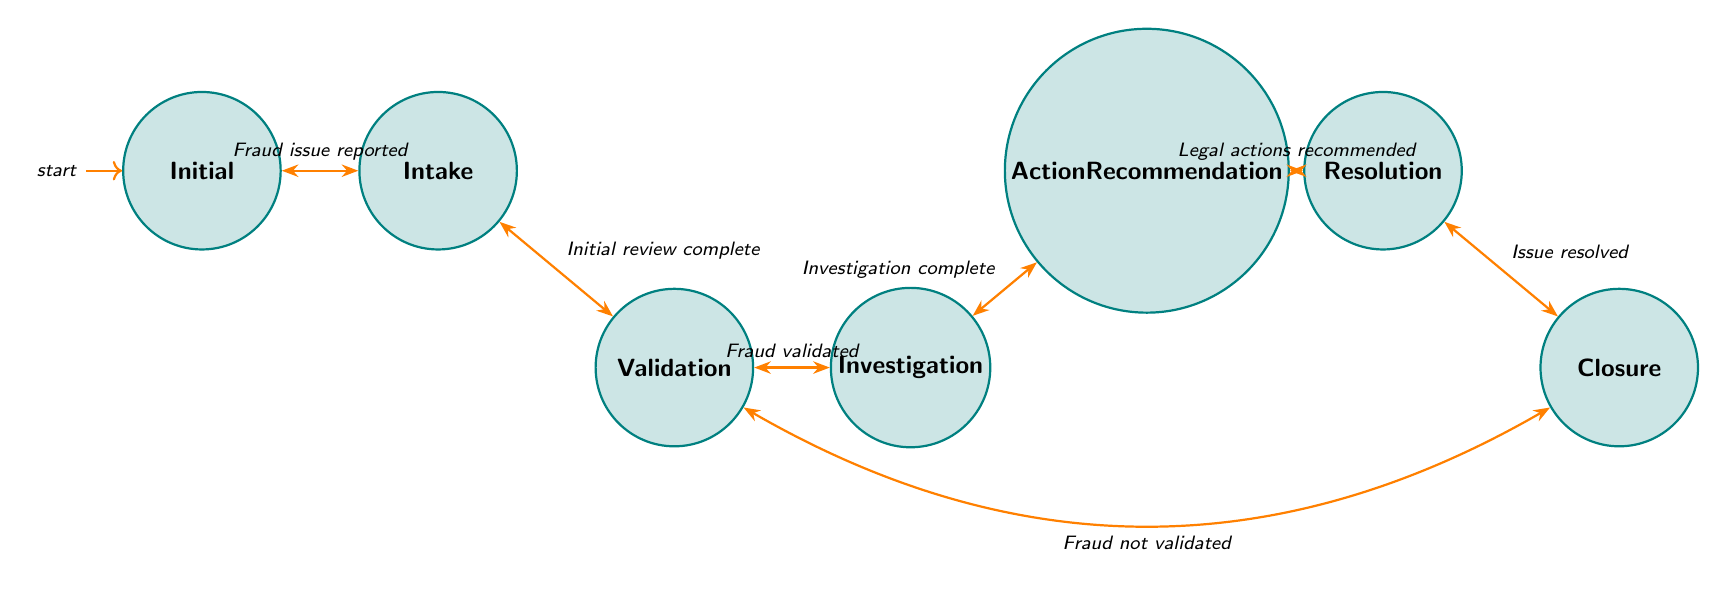What is the initial state in this diagram? The diagram starts with the node labeled "Initial," which represents the beginning of the fraud detection process.
Answer: Initial How many states are in the diagram? By counting each unique node presented in the diagram, we find a total of seven distinct states listed.
Answer: 7 What transition occurs after a fraud issue is reported? The transition labeled "Fraud issue reported" leads from the "Initial" state to the "Intake" state, indicating the first step in the process.
Answer: Intake What are the two possible outcomes after the validation state? After the "Validation" state, either the process proceeds to "Investigation" if the fraud is validated, or it goes to "Closure" if not validated. These outcomes illustrate the decision-making in this part of the process.
Answer: Investigation, Closure Which state represents the resolution of an issue? The state labeled "Resolution" denotes the step where the issue is officially addressed, either through legal action or mediation, concluding that phase of the process.
Answer: Resolution What condition allows a move from "ActionRecommendation" to "Resolution"? The transition from the "ActionRecommendation" state to the "Resolution" state is contingent upon the condition that legal actions are recommended, indicating that the preceding phase's findings necessitate a response.
Answer: Legal actions recommended What happens if the fraud is not validated? If the fraud is not validated during the "Validation" state, the process moves to the "Closure" state, effectively terminating further actions related to that case.
Answer: Closure How many transitions are labeled in the diagram? There are a total of six labeled transitions shown in the diagram which connect the various states, illustrating the flow of the fraud detection and reporting process.
Answer: 6 